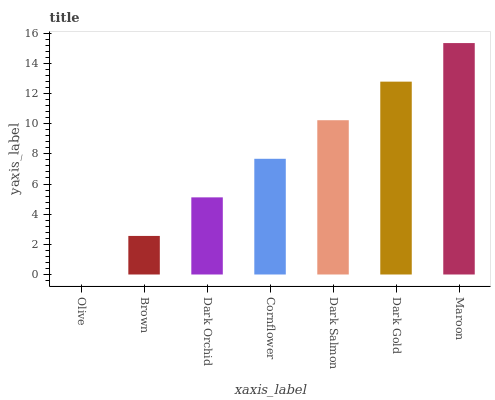Is Brown the minimum?
Answer yes or no. No. Is Brown the maximum?
Answer yes or no. No. Is Brown greater than Olive?
Answer yes or no. Yes. Is Olive less than Brown?
Answer yes or no. Yes. Is Olive greater than Brown?
Answer yes or no. No. Is Brown less than Olive?
Answer yes or no. No. Is Cornflower the high median?
Answer yes or no. Yes. Is Cornflower the low median?
Answer yes or no. Yes. Is Dark Salmon the high median?
Answer yes or no. No. Is Olive the low median?
Answer yes or no. No. 